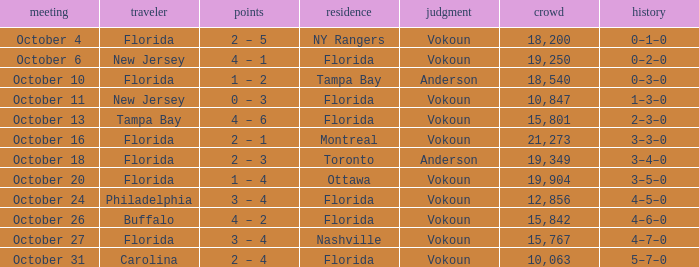Which team was home on October 13? Florida. I'm looking to parse the entire table for insights. Could you assist me with that? {'header': ['meeting', 'traveler', 'points', 'residence', 'judgment', 'crowd', 'history'], 'rows': [['October 4', 'Florida', '2 – 5', 'NY Rangers', 'Vokoun', '18,200', '0–1–0'], ['October 6', 'New Jersey', '4 – 1', 'Florida', 'Vokoun', '19,250', '0–2–0'], ['October 10', 'Florida', '1 – 2', 'Tampa Bay', 'Anderson', '18,540', '0–3–0'], ['October 11', 'New Jersey', '0 – 3', 'Florida', 'Vokoun', '10,847', '1–3–0'], ['October 13', 'Tampa Bay', '4 – 6', 'Florida', 'Vokoun', '15,801', '2–3–0'], ['October 16', 'Florida', '2 – 1', 'Montreal', 'Vokoun', '21,273', '3–3–0'], ['October 18', 'Florida', '2 – 3', 'Toronto', 'Anderson', '19,349', '3–4–0'], ['October 20', 'Florida', '1 – 4', 'Ottawa', 'Vokoun', '19,904', '3–5–0'], ['October 24', 'Philadelphia', '3 – 4', 'Florida', 'Vokoun', '12,856', '4–5–0'], ['October 26', 'Buffalo', '4 – 2', 'Florida', 'Vokoun', '15,842', '4–6–0'], ['October 27', 'Florida', '3 – 4', 'Nashville', 'Vokoun', '15,767', '4–7–0'], ['October 31', 'Carolina', '2 – 4', 'Florida', 'Vokoun', '10,063', '5–7–0']]} 